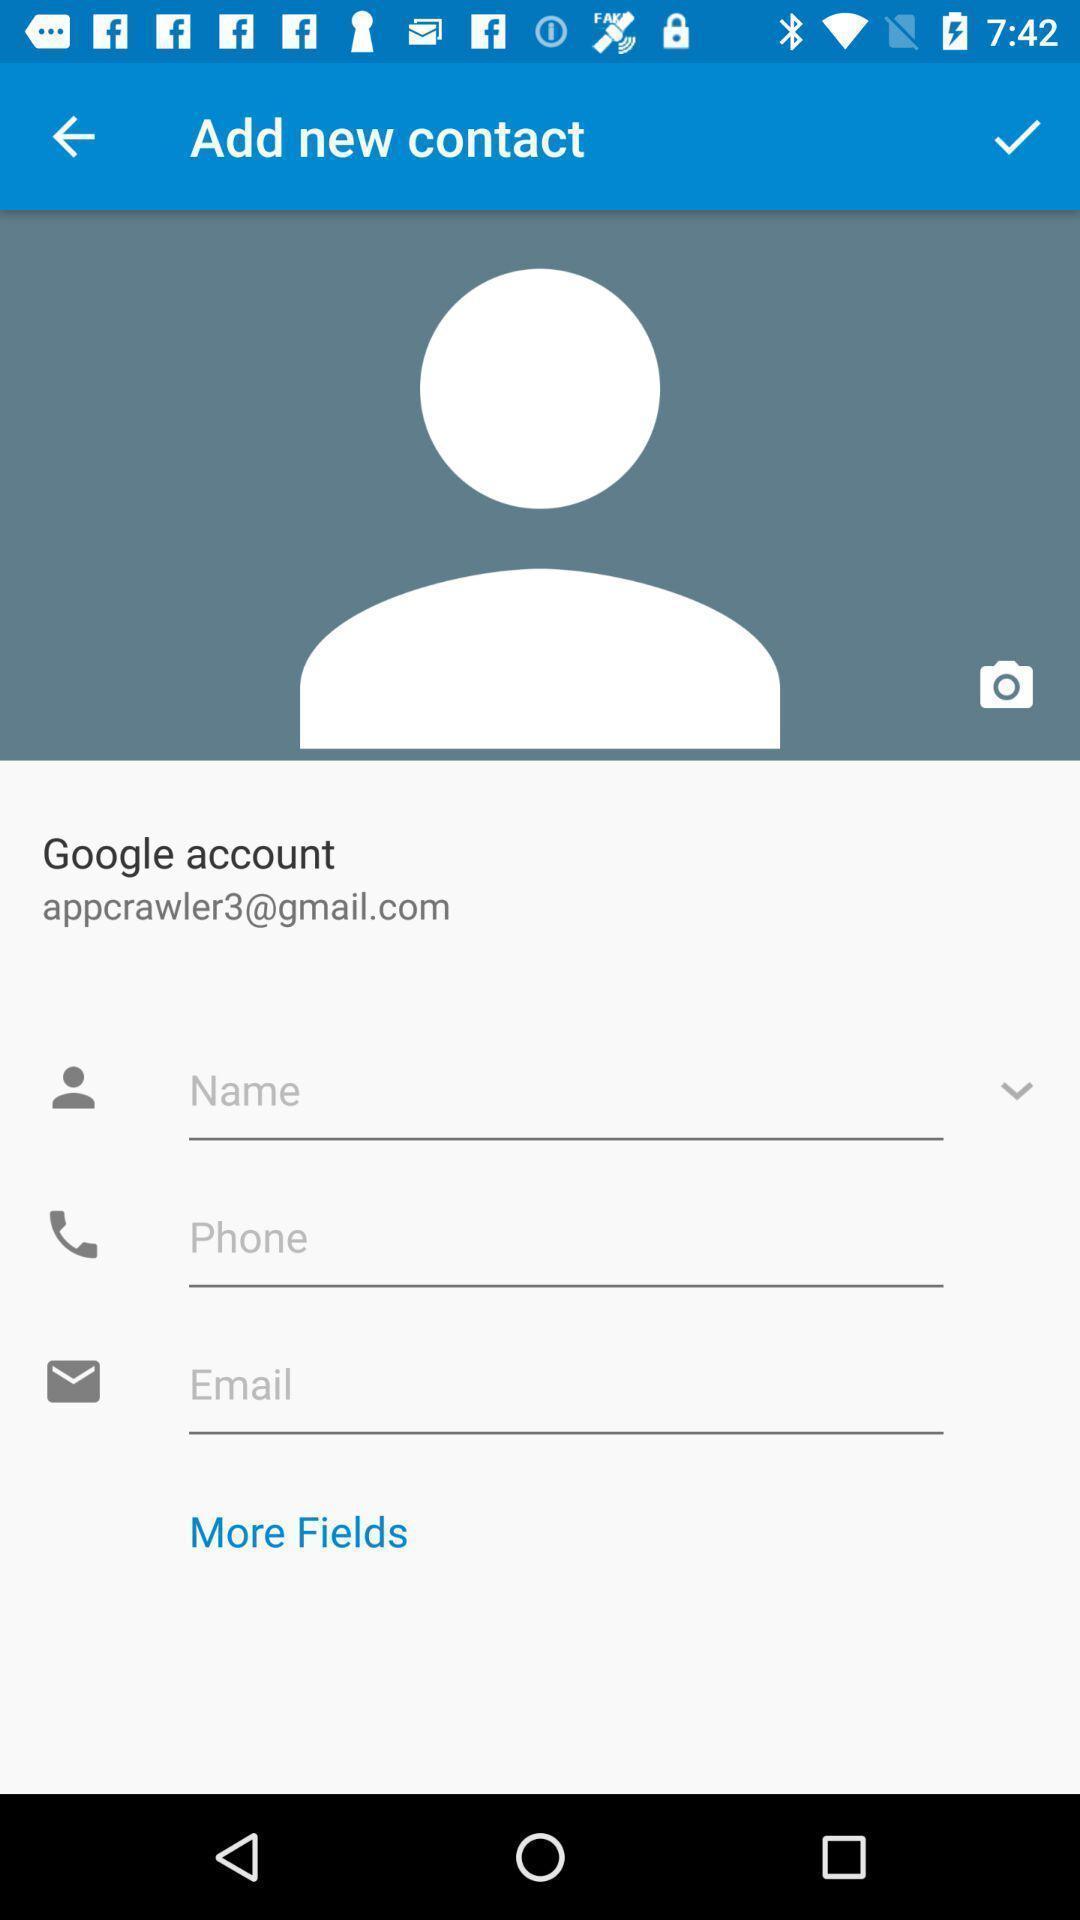Provide a description of this screenshot. Screen showing add account page of a social application. 